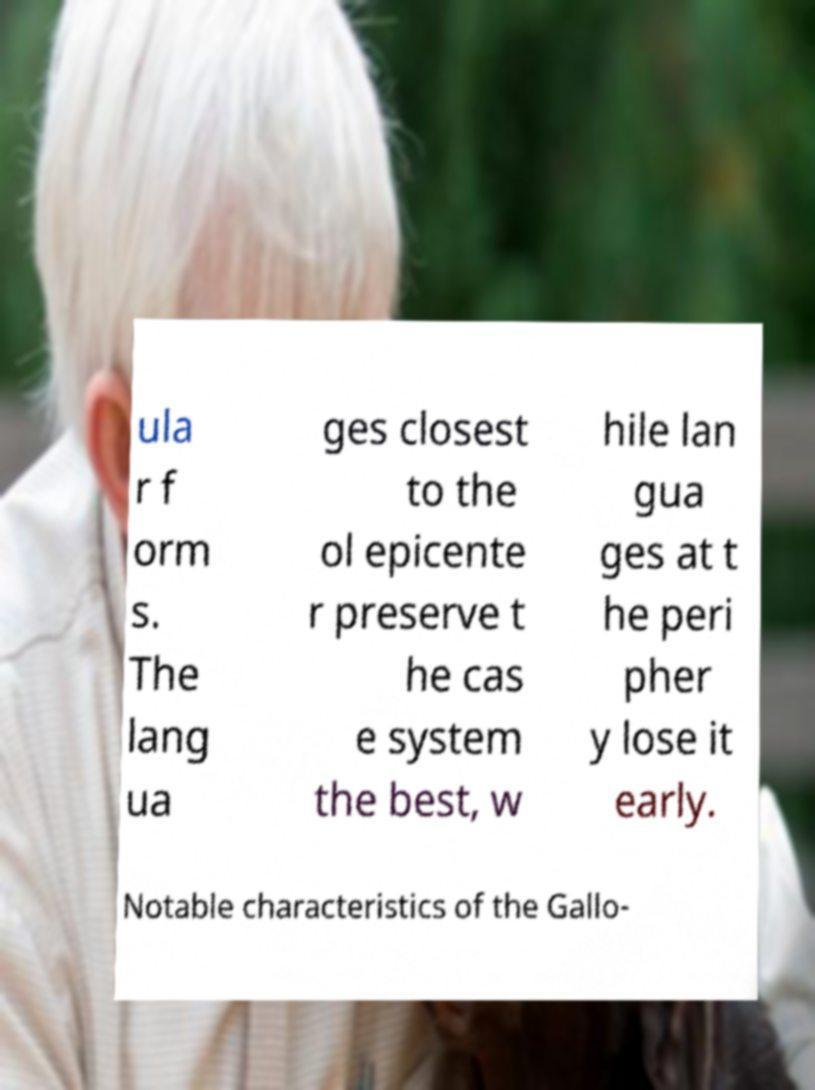Please identify and transcribe the text found in this image. ula r f orm s. The lang ua ges closest to the ol epicente r preserve t he cas e system the best, w hile lan gua ges at t he peri pher y lose it early. Notable characteristics of the Gallo- 